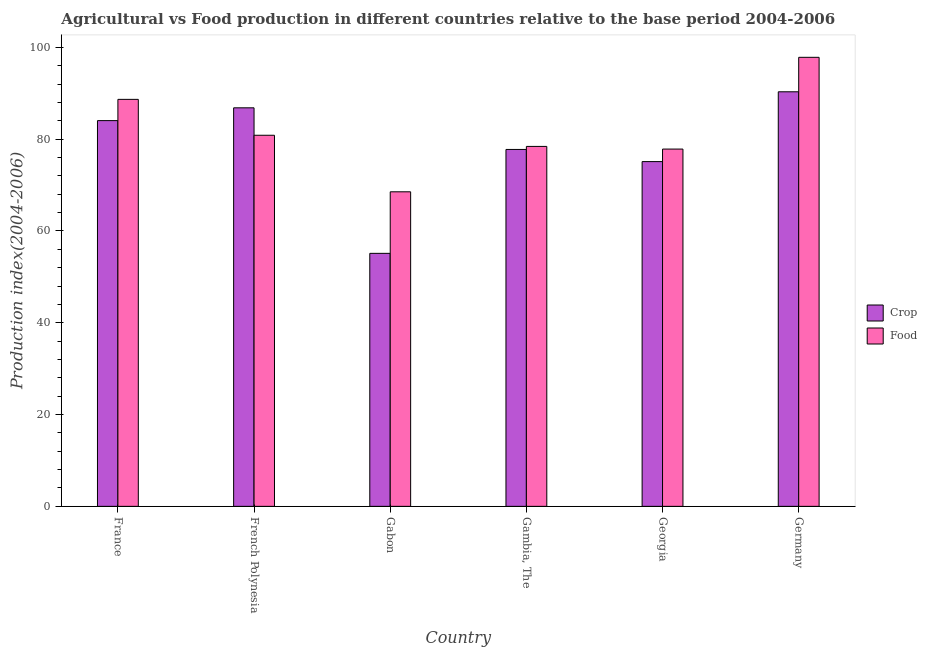How many different coloured bars are there?
Your answer should be compact. 2. How many groups of bars are there?
Provide a short and direct response. 6. Are the number of bars per tick equal to the number of legend labels?
Your answer should be compact. Yes. Are the number of bars on each tick of the X-axis equal?
Your answer should be very brief. Yes. How many bars are there on the 3rd tick from the right?
Your response must be concise. 2. What is the label of the 2nd group of bars from the left?
Keep it short and to the point. French Polynesia. In how many cases, is the number of bars for a given country not equal to the number of legend labels?
Provide a succinct answer. 0. What is the crop production index in Gabon?
Make the answer very short. 55.12. Across all countries, what is the maximum food production index?
Offer a terse response. 97.83. Across all countries, what is the minimum crop production index?
Ensure brevity in your answer.  55.12. In which country was the crop production index minimum?
Your response must be concise. Gabon. What is the total crop production index in the graph?
Provide a short and direct response. 469.18. What is the difference between the food production index in Gabon and that in Gambia, The?
Give a very brief answer. -9.89. What is the difference between the food production index in Georgia and the crop production index in France?
Give a very brief answer. -6.2. What is the average food production index per country?
Keep it short and to the point. 82.02. What is the difference between the food production index and crop production index in French Polynesia?
Provide a short and direct response. -5.98. In how many countries, is the crop production index greater than 4 ?
Offer a terse response. 6. What is the ratio of the crop production index in Gambia, The to that in Germany?
Provide a succinct answer. 0.86. What is the difference between the highest and the second highest crop production index?
Provide a short and direct response. 3.49. What is the difference between the highest and the lowest food production index?
Offer a very short reply. 29.3. Is the sum of the crop production index in Gabon and Gambia, The greater than the maximum food production index across all countries?
Keep it short and to the point. Yes. What does the 1st bar from the left in Germany represents?
Keep it short and to the point. Crop. What does the 1st bar from the right in French Polynesia represents?
Offer a terse response. Food. Are all the bars in the graph horizontal?
Give a very brief answer. No. What is the difference between two consecutive major ticks on the Y-axis?
Provide a succinct answer. 20. Are the values on the major ticks of Y-axis written in scientific E-notation?
Ensure brevity in your answer.  No. Does the graph contain grids?
Your answer should be compact. No. How many legend labels are there?
Give a very brief answer. 2. What is the title of the graph?
Keep it short and to the point. Agricultural vs Food production in different countries relative to the base period 2004-2006. What is the label or title of the X-axis?
Your response must be concise. Country. What is the label or title of the Y-axis?
Your response must be concise. Production index(2004-2006). What is the Production index(2004-2006) of Crop in France?
Give a very brief answer. 84.04. What is the Production index(2004-2006) in Food in France?
Make the answer very short. 88.67. What is the Production index(2004-2006) of Crop in French Polynesia?
Ensure brevity in your answer.  86.83. What is the Production index(2004-2006) in Food in French Polynesia?
Provide a succinct answer. 80.85. What is the Production index(2004-2006) in Crop in Gabon?
Your response must be concise. 55.12. What is the Production index(2004-2006) of Food in Gabon?
Make the answer very short. 68.53. What is the Production index(2004-2006) in Crop in Gambia, The?
Your response must be concise. 77.76. What is the Production index(2004-2006) in Food in Gambia, The?
Give a very brief answer. 78.42. What is the Production index(2004-2006) in Crop in Georgia?
Your answer should be compact. 75.11. What is the Production index(2004-2006) in Food in Georgia?
Your response must be concise. 77.84. What is the Production index(2004-2006) of Crop in Germany?
Provide a short and direct response. 90.32. What is the Production index(2004-2006) of Food in Germany?
Your response must be concise. 97.83. Across all countries, what is the maximum Production index(2004-2006) in Crop?
Give a very brief answer. 90.32. Across all countries, what is the maximum Production index(2004-2006) of Food?
Give a very brief answer. 97.83. Across all countries, what is the minimum Production index(2004-2006) in Crop?
Give a very brief answer. 55.12. Across all countries, what is the minimum Production index(2004-2006) of Food?
Your answer should be very brief. 68.53. What is the total Production index(2004-2006) of Crop in the graph?
Your answer should be very brief. 469.18. What is the total Production index(2004-2006) in Food in the graph?
Your answer should be very brief. 492.14. What is the difference between the Production index(2004-2006) of Crop in France and that in French Polynesia?
Make the answer very short. -2.79. What is the difference between the Production index(2004-2006) in Food in France and that in French Polynesia?
Keep it short and to the point. 7.82. What is the difference between the Production index(2004-2006) of Crop in France and that in Gabon?
Give a very brief answer. 28.92. What is the difference between the Production index(2004-2006) in Food in France and that in Gabon?
Keep it short and to the point. 20.14. What is the difference between the Production index(2004-2006) of Crop in France and that in Gambia, The?
Ensure brevity in your answer.  6.28. What is the difference between the Production index(2004-2006) of Food in France and that in Gambia, The?
Your answer should be very brief. 10.25. What is the difference between the Production index(2004-2006) in Crop in France and that in Georgia?
Offer a very short reply. 8.93. What is the difference between the Production index(2004-2006) in Food in France and that in Georgia?
Your response must be concise. 10.83. What is the difference between the Production index(2004-2006) of Crop in France and that in Germany?
Provide a short and direct response. -6.28. What is the difference between the Production index(2004-2006) of Food in France and that in Germany?
Offer a terse response. -9.16. What is the difference between the Production index(2004-2006) in Crop in French Polynesia and that in Gabon?
Offer a terse response. 31.71. What is the difference between the Production index(2004-2006) of Food in French Polynesia and that in Gabon?
Your response must be concise. 12.32. What is the difference between the Production index(2004-2006) of Crop in French Polynesia and that in Gambia, The?
Make the answer very short. 9.07. What is the difference between the Production index(2004-2006) in Food in French Polynesia and that in Gambia, The?
Provide a short and direct response. 2.43. What is the difference between the Production index(2004-2006) of Crop in French Polynesia and that in Georgia?
Ensure brevity in your answer.  11.72. What is the difference between the Production index(2004-2006) of Food in French Polynesia and that in Georgia?
Your answer should be compact. 3.01. What is the difference between the Production index(2004-2006) in Crop in French Polynesia and that in Germany?
Provide a succinct answer. -3.49. What is the difference between the Production index(2004-2006) of Food in French Polynesia and that in Germany?
Keep it short and to the point. -16.98. What is the difference between the Production index(2004-2006) in Crop in Gabon and that in Gambia, The?
Give a very brief answer. -22.64. What is the difference between the Production index(2004-2006) in Food in Gabon and that in Gambia, The?
Provide a short and direct response. -9.89. What is the difference between the Production index(2004-2006) in Crop in Gabon and that in Georgia?
Your answer should be compact. -19.99. What is the difference between the Production index(2004-2006) of Food in Gabon and that in Georgia?
Your answer should be very brief. -9.31. What is the difference between the Production index(2004-2006) of Crop in Gabon and that in Germany?
Offer a very short reply. -35.2. What is the difference between the Production index(2004-2006) of Food in Gabon and that in Germany?
Keep it short and to the point. -29.3. What is the difference between the Production index(2004-2006) in Crop in Gambia, The and that in Georgia?
Keep it short and to the point. 2.65. What is the difference between the Production index(2004-2006) of Food in Gambia, The and that in Georgia?
Offer a very short reply. 0.58. What is the difference between the Production index(2004-2006) in Crop in Gambia, The and that in Germany?
Make the answer very short. -12.56. What is the difference between the Production index(2004-2006) in Food in Gambia, The and that in Germany?
Offer a very short reply. -19.41. What is the difference between the Production index(2004-2006) in Crop in Georgia and that in Germany?
Offer a very short reply. -15.21. What is the difference between the Production index(2004-2006) in Food in Georgia and that in Germany?
Offer a very short reply. -19.99. What is the difference between the Production index(2004-2006) in Crop in France and the Production index(2004-2006) in Food in French Polynesia?
Ensure brevity in your answer.  3.19. What is the difference between the Production index(2004-2006) of Crop in France and the Production index(2004-2006) of Food in Gabon?
Offer a terse response. 15.51. What is the difference between the Production index(2004-2006) in Crop in France and the Production index(2004-2006) in Food in Gambia, The?
Give a very brief answer. 5.62. What is the difference between the Production index(2004-2006) in Crop in France and the Production index(2004-2006) in Food in Germany?
Your response must be concise. -13.79. What is the difference between the Production index(2004-2006) in Crop in French Polynesia and the Production index(2004-2006) in Food in Gambia, The?
Make the answer very short. 8.41. What is the difference between the Production index(2004-2006) of Crop in French Polynesia and the Production index(2004-2006) of Food in Georgia?
Your answer should be compact. 8.99. What is the difference between the Production index(2004-2006) in Crop in Gabon and the Production index(2004-2006) in Food in Gambia, The?
Keep it short and to the point. -23.3. What is the difference between the Production index(2004-2006) of Crop in Gabon and the Production index(2004-2006) of Food in Georgia?
Give a very brief answer. -22.72. What is the difference between the Production index(2004-2006) of Crop in Gabon and the Production index(2004-2006) of Food in Germany?
Offer a terse response. -42.71. What is the difference between the Production index(2004-2006) in Crop in Gambia, The and the Production index(2004-2006) in Food in Georgia?
Your response must be concise. -0.08. What is the difference between the Production index(2004-2006) in Crop in Gambia, The and the Production index(2004-2006) in Food in Germany?
Your answer should be compact. -20.07. What is the difference between the Production index(2004-2006) of Crop in Georgia and the Production index(2004-2006) of Food in Germany?
Ensure brevity in your answer.  -22.72. What is the average Production index(2004-2006) of Crop per country?
Your answer should be very brief. 78.2. What is the average Production index(2004-2006) in Food per country?
Give a very brief answer. 82.02. What is the difference between the Production index(2004-2006) in Crop and Production index(2004-2006) in Food in France?
Your answer should be very brief. -4.63. What is the difference between the Production index(2004-2006) in Crop and Production index(2004-2006) in Food in French Polynesia?
Give a very brief answer. 5.98. What is the difference between the Production index(2004-2006) in Crop and Production index(2004-2006) in Food in Gabon?
Provide a succinct answer. -13.41. What is the difference between the Production index(2004-2006) in Crop and Production index(2004-2006) in Food in Gambia, The?
Your response must be concise. -0.66. What is the difference between the Production index(2004-2006) of Crop and Production index(2004-2006) of Food in Georgia?
Your answer should be very brief. -2.73. What is the difference between the Production index(2004-2006) of Crop and Production index(2004-2006) of Food in Germany?
Your answer should be very brief. -7.51. What is the ratio of the Production index(2004-2006) in Crop in France to that in French Polynesia?
Ensure brevity in your answer.  0.97. What is the ratio of the Production index(2004-2006) of Food in France to that in French Polynesia?
Your answer should be very brief. 1.1. What is the ratio of the Production index(2004-2006) of Crop in France to that in Gabon?
Provide a short and direct response. 1.52. What is the ratio of the Production index(2004-2006) in Food in France to that in Gabon?
Offer a terse response. 1.29. What is the ratio of the Production index(2004-2006) in Crop in France to that in Gambia, The?
Give a very brief answer. 1.08. What is the ratio of the Production index(2004-2006) of Food in France to that in Gambia, The?
Ensure brevity in your answer.  1.13. What is the ratio of the Production index(2004-2006) in Crop in France to that in Georgia?
Your answer should be compact. 1.12. What is the ratio of the Production index(2004-2006) in Food in France to that in Georgia?
Your answer should be very brief. 1.14. What is the ratio of the Production index(2004-2006) of Crop in France to that in Germany?
Offer a terse response. 0.93. What is the ratio of the Production index(2004-2006) of Food in France to that in Germany?
Your response must be concise. 0.91. What is the ratio of the Production index(2004-2006) of Crop in French Polynesia to that in Gabon?
Provide a short and direct response. 1.58. What is the ratio of the Production index(2004-2006) in Food in French Polynesia to that in Gabon?
Offer a very short reply. 1.18. What is the ratio of the Production index(2004-2006) in Crop in French Polynesia to that in Gambia, The?
Your answer should be compact. 1.12. What is the ratio of the Production index(2004-2006) of Food in French Polynesia to that in Gambia, The?
Offer a terse response. 1.03. What is the ratio of the Production index(2004-2006) of Crop in French Polynesia to that in Georgia?
Provide a short and direct response. 1.16. What is the ratio of the Production index(2004-2006) of Food in French Polynesia to that in Georgia?
Your response must be concise. 1.04. What is the ratio of the Production index(2004-2006) of Crop in French Polynesia to that in Germany?
Your answer should be compact. 0.96. What is the ratio of the Production index(2004-2006) in Food in French Polynesia to that in Germany?
Your answer should be very brief. 0.83. What is the ratio of the Production index(2004-2006) in Crop in Gabon to that in Gambia, The?
Provide a short and direct response. 0.71. What is the ratio of the Production index(2004-2006) in Food in Gabon to that in Gambia, The?
Give a very brief answer. 0.87. What is the ratio of the Production index(2004-2006) of Crop in Gabon to that in Georgia?
Make the answer very short. 0.73. What is the ratio of the Production index(2004-2006) in Food in Gabon to that in Georgia?
Ensure brevity in your answer.  0.88. What is the ratio of the Production index(2004-2006) in Crop in Gabon to that in Germany?
Provide a short and direct response. 0.61. What is the ratio of the Production index(2004-2006) in Food in Gabon to that in Germany?
Offer a very short reply. 0.7. What is the ratio of the Production index(2004-2006) of Crop in Gambia, The to that in Georgia?
Provide a short and direct response. 1.04. What is the ratio of the Production index(2004-2006) in Food in Gambia, The to that in Georgia?
Your response must be concise. 1.01. What is the ratio of the Production index(2004-2006) in Crop in Gambia, The to that in Germany?
Ensure brevity in your answer.  0.86. What is the ratio of the Production index(2004-2006) of Food in Gambia, The to that in Germany?
Provide a short and direct response. 0.8. What is the ratio of the Production index(2004-2006) of Crop in Georgia to that in Germany?
Provide a short and direct response. 0.83. What is the ratio of the Production index(2004-2006) of Food in Georgia to that in Germany?
Make the answer very short. 0.8. What is the difference between the highest and the second highest Production index(2004-2006) in Crop?
Your answer should be compact. 3.49. What is the difference between the highest and the second highest Production index(2004-2006) of Food?
Provide a short and direct response. 9.16. What is the difference between the highest and the lowest Production index(2004-2006) in Crop?
Keep it short and to the point. 35.2. What is the difference between the highest and the lowest Production index(2004-2006) in Food?
Ensure brevity in your answer.  29.3. 